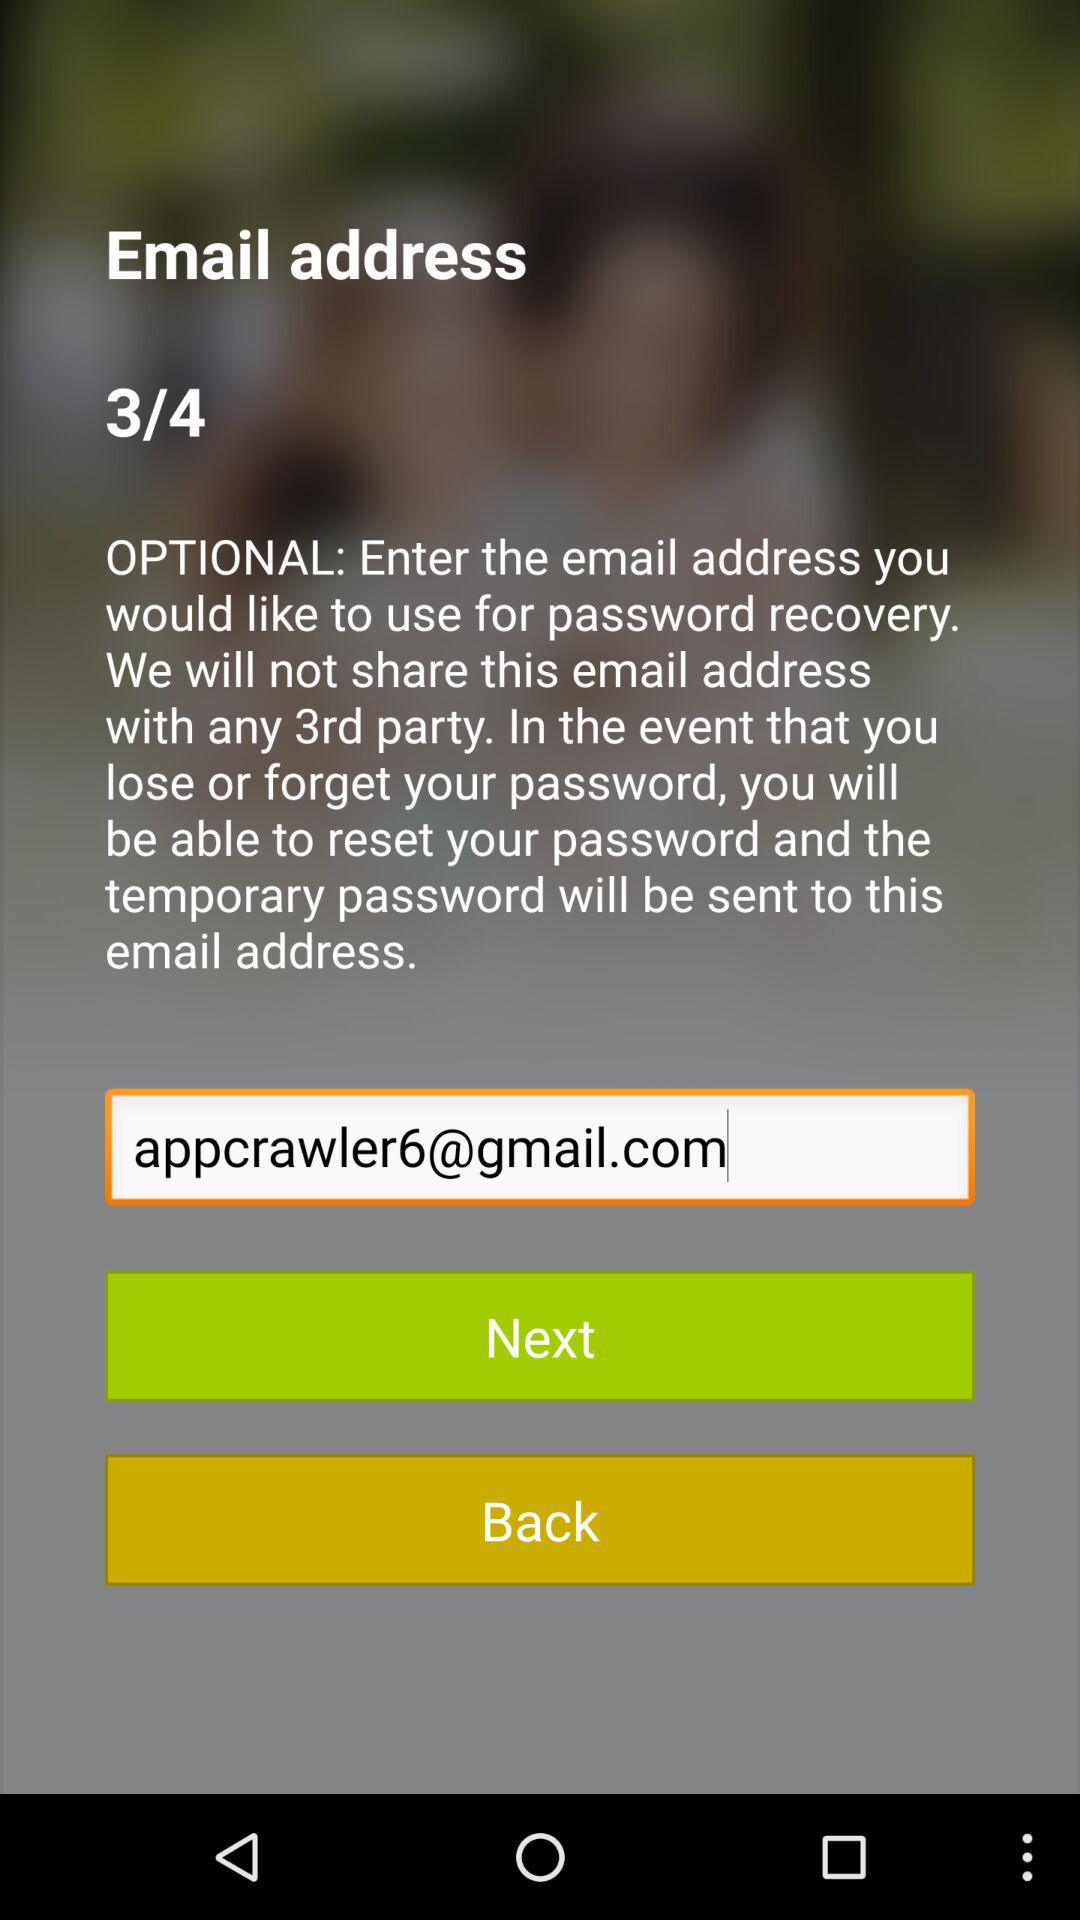On which page am I? You are on the third page. 